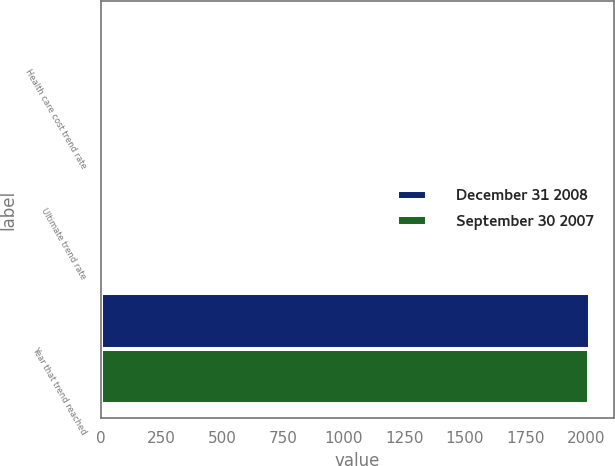<chart> <loc_0><loc_0><loc_500><loc_500><stacked_bar_chart><ecel><fcel>Health care cost trend rate<fcel>Ultimate trend rate<fcel>Year that trend reached<nl><fcel>December 31 2008<fcel>7.5<fcel>5<fcel>2014<nl><fcel>September 30 2007<fcel>7.5<fcel>5<fcel>2013<nl></chart> 